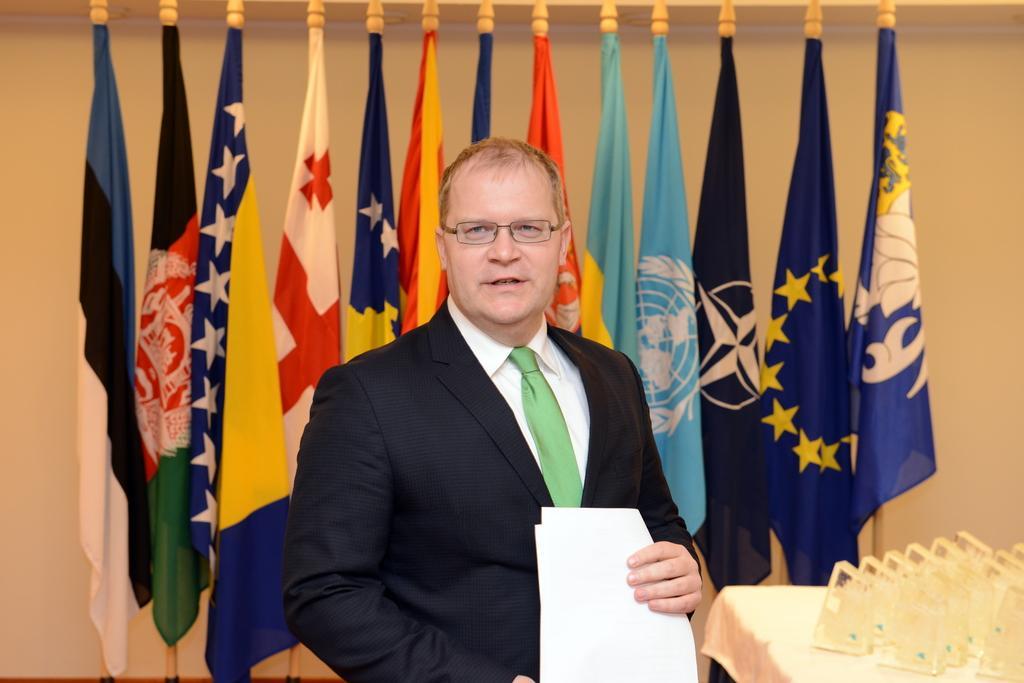Describe this image in one or two sentences. In the center of the image there is a person standing wearing a suit holding a paper in his hand. In the background of the image there are flags and wall. 